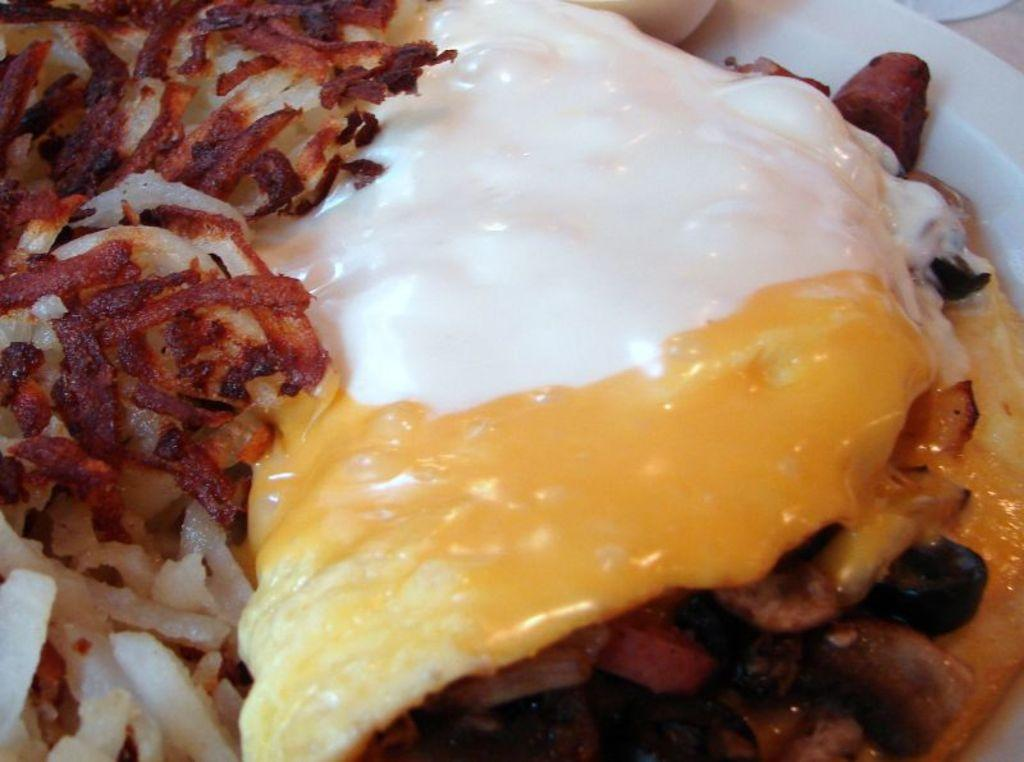What is present in the image related to food? There is food in the image. How is the food arranged or presented in the image? The food is in a plate. What date is marked on the calendar in the image? There is no calendar present in the image. How does the bean contribute to the wealth of the person in the image? There is no bean or reference to wealth in the image. 